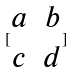Convert formula to latex. <formula><loc_0><loc_0><loc_500><loc_500>[ \begin{matrix} a & b \\ c & d \end{matrix} ]</formula> 